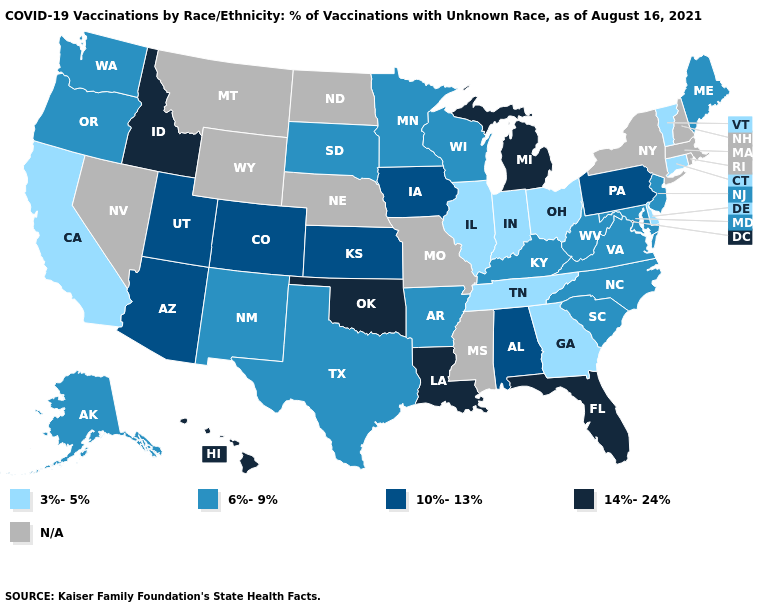Name the states that have a value in the range 10%-13%?
Quick response, please. Alabama, Arizona, Colorado, Iowa, Kansas, Pennsylvania, Utah. What is the value of California?
Keep it brief. 3%-5%. Among the states that border Tennessee , which have the highest value?
Keep it brief. Alabama. What is the value of Pennsylvania?
Be succinct. 10%-13%. Name the states that have a value in the range N/A?
Keep it brief. Massachusetts, Mississippi, Missouri, Montana, Nebraska, Nevada, New Hampshire, New York, North Dakota, Rhode Island, Wyoming. What is the value of Iowa?
Keep it brief. 10%-13%. Name the states that have a value in the range 14%-24%?
Write a very short answer. Florida, Hawaii, Idaho, Louisiana, Michigan, Oklahoma. What is the value of Connecticut?
Give a very brief answer. 3%-5%. What is the value of Ohio?
Concise answer only. 3%-5%. Is the legend a continuous bar?
Give a very brief answer. No. What is the value of Hawaii?
Concise answer only. 14%-24%. Which states hav the highest value in the South?
Give a very brief answer. Florida, Louisiana, Oklahoma. 